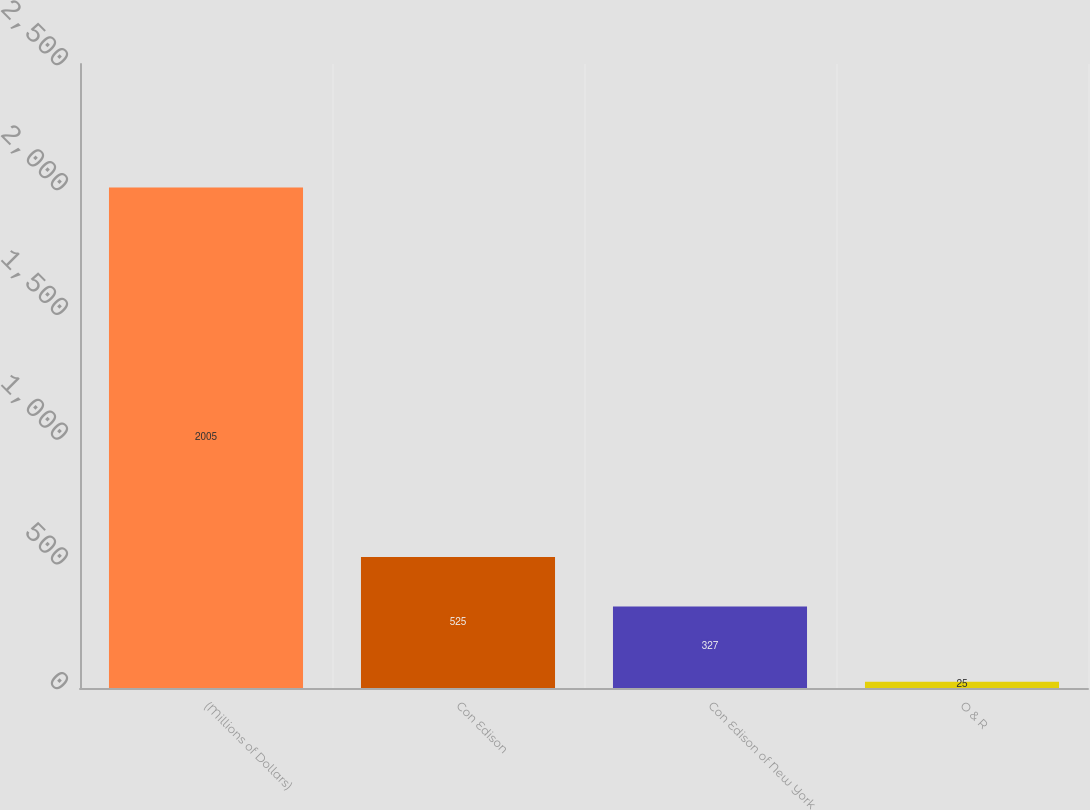Convert chart to OTSL. <chart><loc_0><loc_0><loc_500><loc_500><bar_chart><fcel>(Millions of Dollars)<fcel>Con Edison<fcel>Con Edison of New York<fcel>O & R<nl><fcel>2005<fcel>525<fcel>327<fcel>25<nl></chart> 